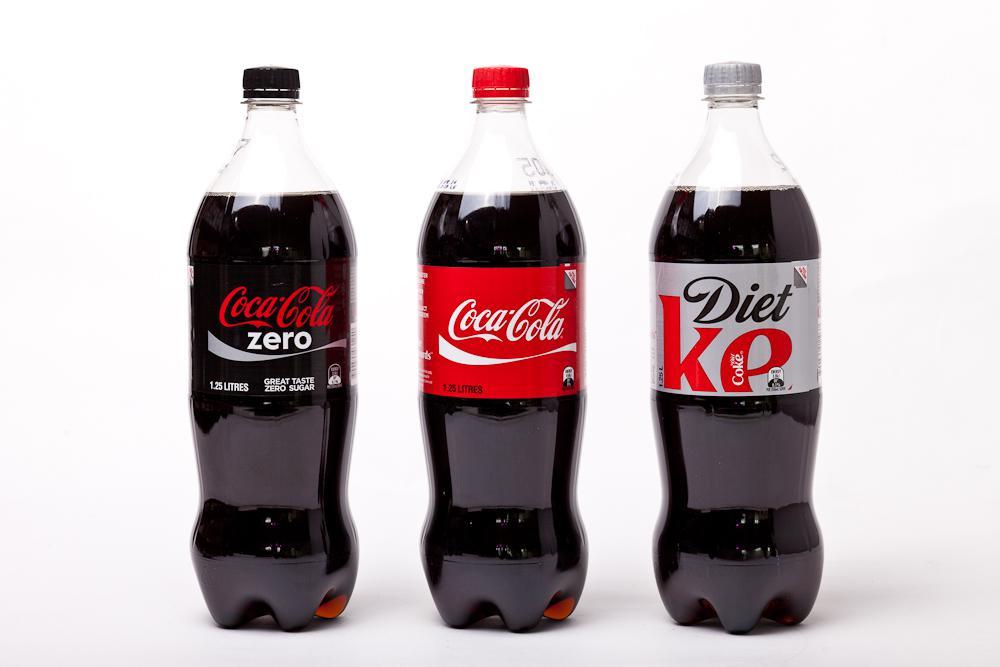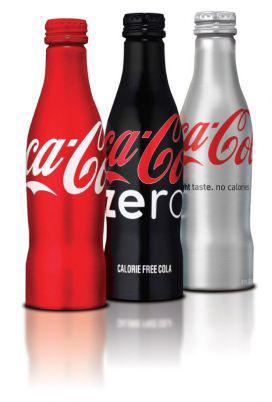The first image is the image on the left, the second image is the image on the right. For the images displayed, is the sentence "The left image includes three varieties of one brand of soda in transparent plastic bottles, which are in a row but not touching." factually correct? Answer yes or no. Yes. The first image is the image on the left, the second image is the image on the right. For the images displayed, is the sentence "The right image contains at least three bottles." factually correct? Answer yes or no. Yes. 